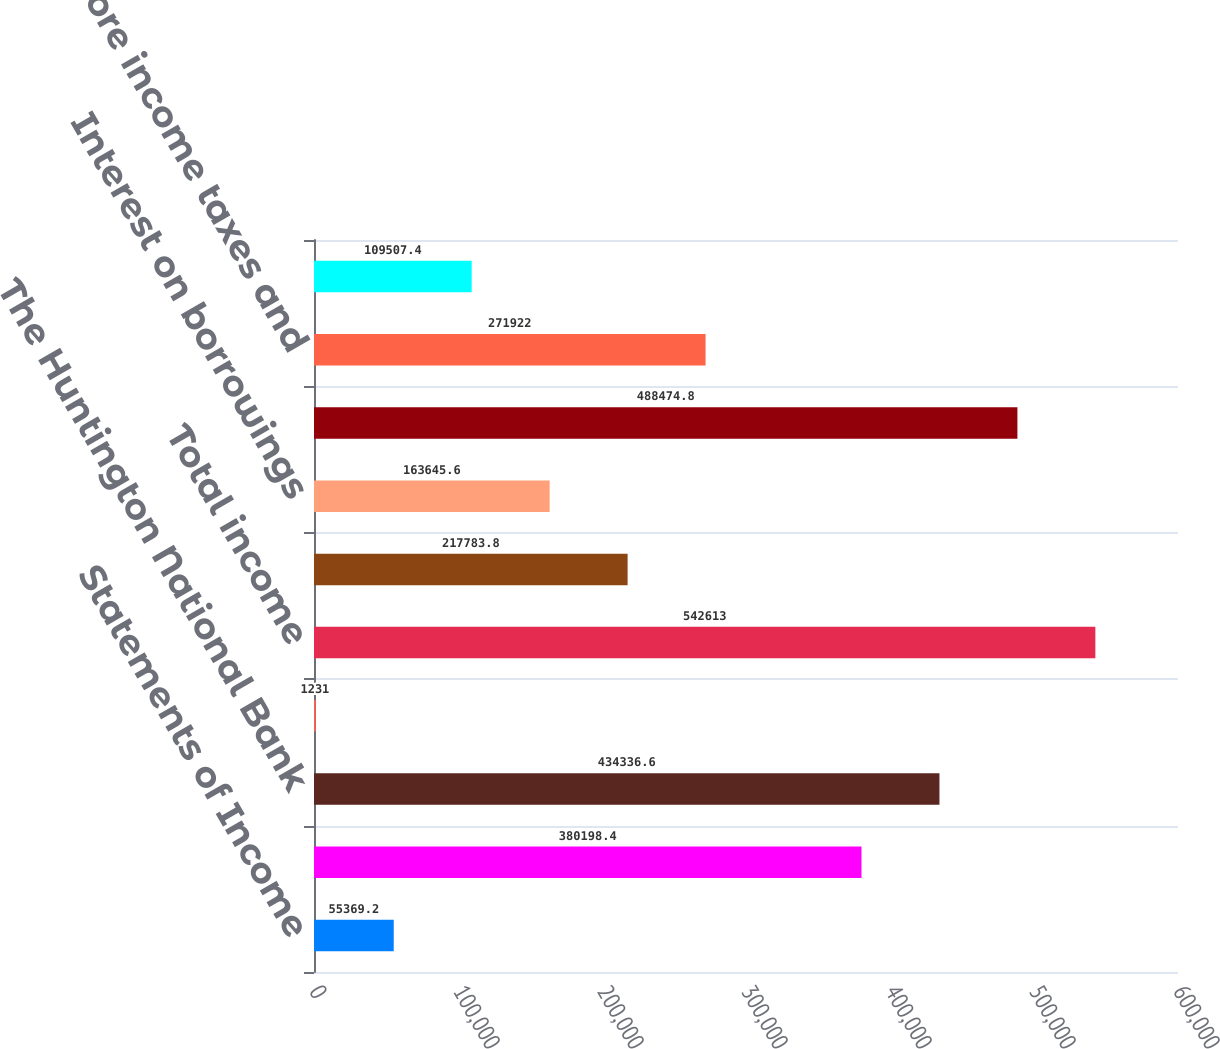Convert chart. <chart><loc_0><loc_0><loc_500><loc_500><bar_chart><fcel>Statements of Income<fcel>Non-bank subsidiaries<fcel>The Huntington National Bank<fcel>Other<fcel>Total income<fcel>Personnel costs<fcel>Interest on borrowings<fcel>Total expense<fcel>Income before income taxes and<fcel>Income taxes<nl><fcel>55369.2<fcel>380198<fcel>434337<fcel>1231<fcel>542613<fcel>217784<fcel>163646<fcel>488475<fcel>271922<fcel>109507<nl></chart> 